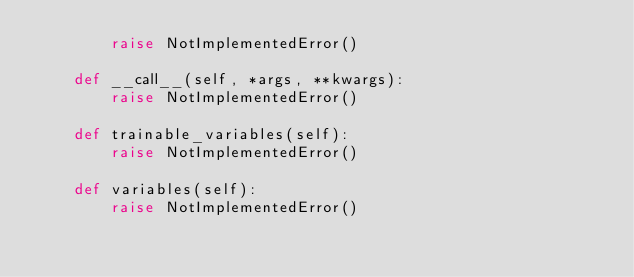<code> <loc_0><loc_0><loc_500><loc_500><_Python_>        raise NotImplementedError()

    def __call__(self, *args, **kwargs):
        raise NotImplementedError()

    def trainable_variables(self):
        raise NotImplementedError()

    def variables(self):
        raise NotImplementedError()</code> 